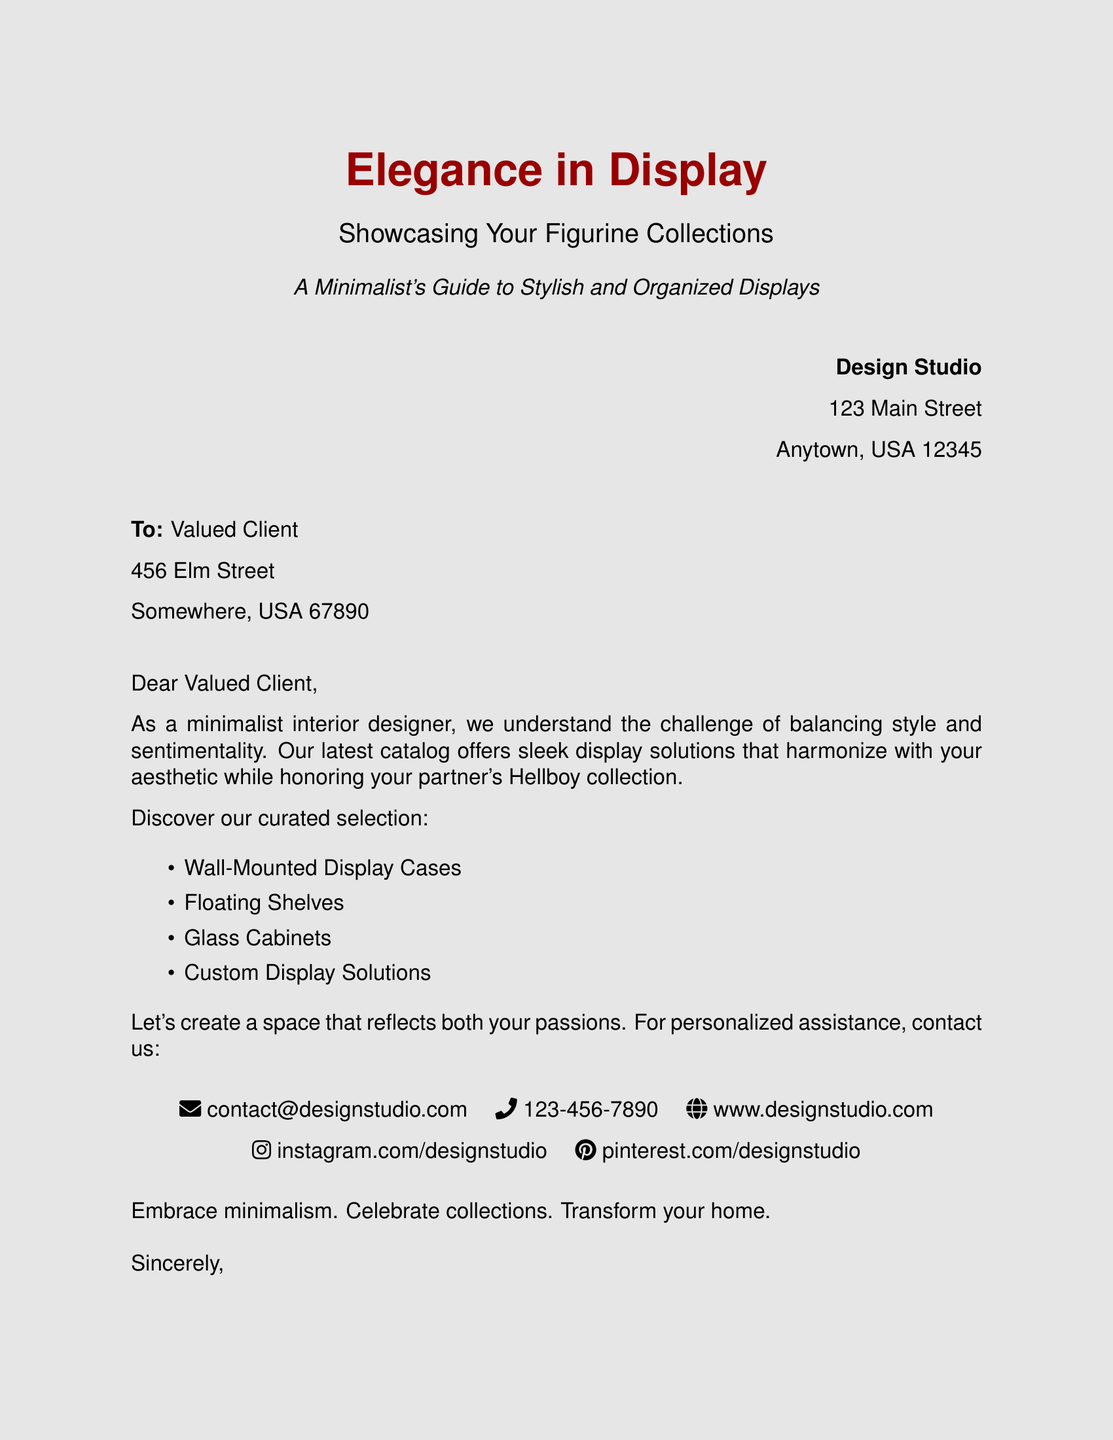what is the title of the catalog? The title of the catalog is prominently displayed in a large font at the top of the document.
Answer: Elegance in Display who is the intended recipient of the letter? The letter is addressed to a specific client, which can be found in the address section.
Answer: Valued Client how many display solutions are mentioned? The document lists the display solutions in a bulleted format indicating the total amount.
Answer: Four what are two types of display solutions offered? The catalog section includes a list of various display solutions with examples given.
Answer: Wall-Mounted Display Cases, Floating Shelves what color is the background of the page? The document specifies the background color used for the page in its design details.
Answer: Minimalist gray what is the contact email provided? The catalog includes contact information, including an email which is explicitly stated.
Answer: contact@designstudio.com what is the overall theme of the design solutions offered? The tone and direction of the catalog's offerings focus on a harmonious blend of aesthetics and organization.
Answer: Minimalism who is the sender of the document? The closing of the letter indicates the organization responsible for the communication.
Answer: Your Design Studio Team 